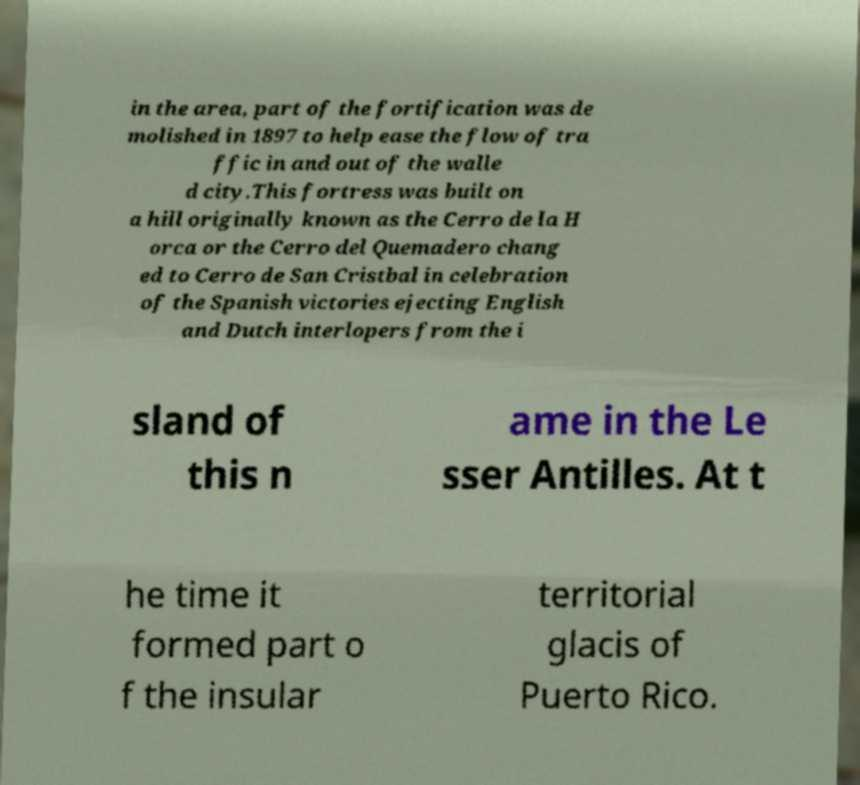I need the written content from this picture converted into text. Can you do that? in the area, part of the fortification was de molished in 1897 to help ease the flow of tra ffic in and out of the walle d city.This fortress was built on a hill originally known as the Cerro de la H orca or the Cerro del Quemadero chang ed to Cerro de San Cristbal in celebration of the Spanish victories ejecting English and Dutch interlopers from the i sland of this n ame in the Le sser Antilles. At t he time it formed part o f the insular territorial glacis of Puerto Rico. 